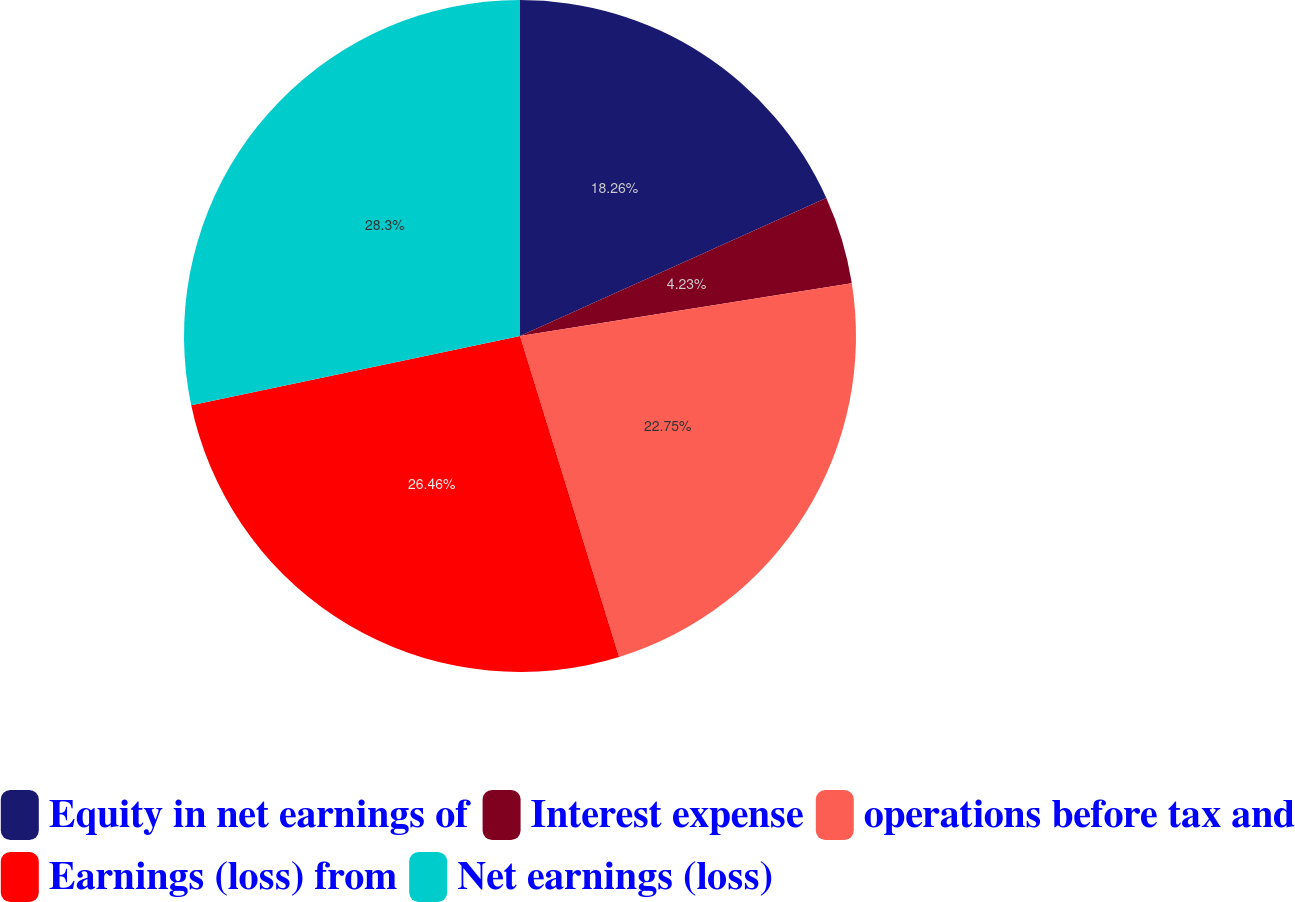Convert chart. <chart><loc_0><loc_0><loc_500><loc_500><pie_chart><fcel>Equity in net earnings of<fcel>Interest expense<fcel>operations before tax and<fcel>Earnings (loss) from<fcel>Net earnings (loss)<nl><fcel>18.26%<fcel>4.23%<fcel>22.75%<fcel>26.46%<fcel>28.31%<nl></chart> 